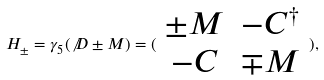Convert formula to latex. <formula><loc_0><loc_0><loc_500><loc_500>H _ { \pm } = \gamma _ { 5 } ( \not D \pm M ) = ( \begin{array} { c c } \pm M & - C ^ { \dagger } \\ - C & \mp M \end{array} ) ,</formula> 